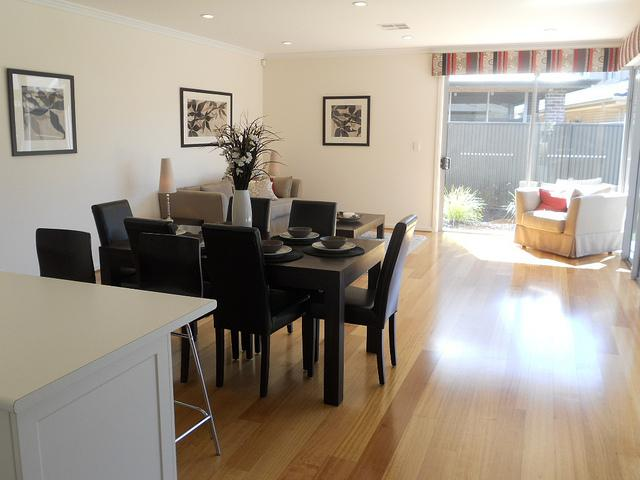What color is the seat on the couch in the corner window? white 